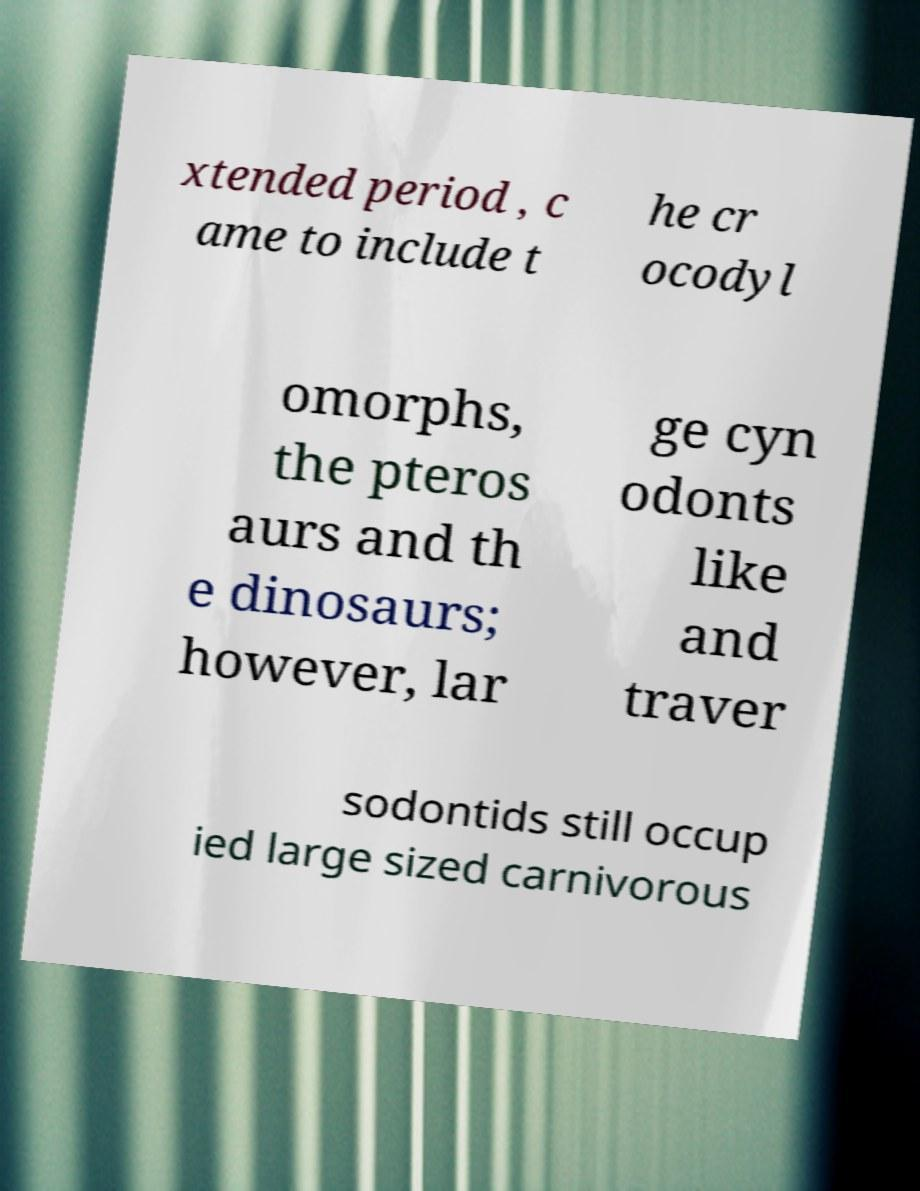Can you read and provide the text displayed in the image?This photo seems to have some interesting text. Can you extract and type it out for me? xtended period , c ame to include t he cr ocodyl omorphs, the pteros aurs and th e dinosaurs; however, lar ge cyn odonts like and traver sodontids still occup ied large sized carnivorous 